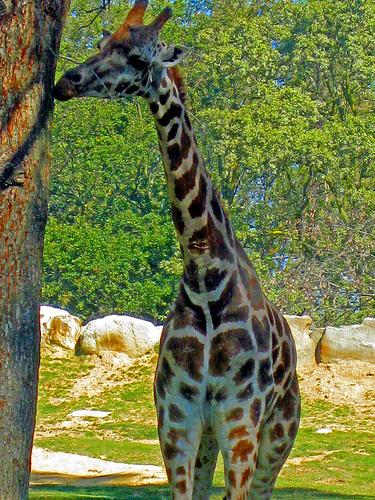Describe the state of the grass where the giraffe is standing. The grass is a mixture of green and exposed dirt, possibly due to the giraffe and other animals' movements in the area. Examine the overall sentiment or mood conveyed by the image. The image conveys a serene and peaceful mood, with a giraffe in its natural habitat surrounded by lush greenery, large rocks, and clear blue skies. Comment on the relationship between the giraffe and its surroundings. The giraffe appears to be comfortable and at ease in its natural environment, interacting with its surroundings by eating leaves from the tree and standing near various elements like rocks and grass. What is the state of the flora surrounding the giraffe? The flora includes bright yellow and greenish-yellow leaves on tall trees, green bushes, and branches with deep green leaves. Identify any anomalies or oddities within the image. A "zebra's mouth" is mentioned on a tree, which is likely an error, as there are no zebras in the image. What kind of tree is the giraffe interacting with in the image? The specific tree type is not identified, but it has a tall and rough trunk with bright yellow and deep green leaves, and branches that extend from the tree. Identify any striking features of the giraffe in the image. The giraffe has long neck, long legs, big and dark eye, ossicones, and a small white spot on its body. Provide a brief description of the most prominent figure in the image. A tall spotted brown and white giraffe is eating from a tree and touching it with its mouth. Explain the environment where the giraffe is standing. The giraffe is standing next to a tall tree, surrounded by green grass and large rocks, with green trees and blue sky peeking through the branches. Analyze the textures and colors of the tree trunk and rocks in the image. The tree trunk has a rough texture with gray and brown colors and black lines, while the large rocks are tan and brown with a big appearance. What type of leaves can be seen on the tall trees in the image? Bright greenish-yellow leaves Can you find a swimming turtle near the tall tree? There is no mention of any turtle or aquatic features in the image. The instruction introduces an object that doesn't exist in the image. Based on the background elements, describe the environment in the image. The environment consists of green grass, large rocks, green bushes, and tall trees with greenish-yellow leaves. Describe the grass area in the picture. The grass is green with patches of exposed dirt. Evaluate the presence of zebras in the image. There are no zebras in the image. Is there a red fruit hanging from the branches with deep green leaves? There is no mention of any fruit or red color in the given information. The instruction introduces an additional attribute and object that doesn't exist in the image. What activity is the giraffe performing in the image? The giraffe is eating leaves from the tree. Are there any flamingos standing on one leg in the background? There is no mention of any flamingos or other animals apart from the giraffe in the given information. The instruction introduces an object that doesn't exist in the image. Describe the nature of the tree trunk in the image. The tree trunk is rough with grey and brown tones. Does the giraffe have bright pink spots all over its body? The given information mentions that the giraffe is brown and has a long spotted neck but doesn't mention any color for the spots. The instruction introduces an attribute (pink spots) that doesn't exist in the image. Can you see the blue sky through the tree branches? Yes, the blue sky is peeking through the branches. Is there a rainbow visible through the greenish yellow leaves on the tall trees? There is no mention of a rainbow in the given information. The instruction introduces an attribute that doesn't exist in the image. What is behind the giraffe in the image? Rocks and green bushes are behind the giraffe. Examine the two lines on the tree trunk and describe them. One line is a long black line and the other is a smaller black fading line. Are the giraffe's ossicones visible in the image? Yes, the giraffe's ossicones are visible. Create a description of the giraffe's body features in the image. The giraffe has a long neck, long legs, a spotted body, big and dark eyes, and ossicones on its head. What is the color of the giraffe in the image? Brown and white Is there an object in the scene that could be referred to as a square white stone? Yes, there is a square white stone on the ground. How many tree branches can you see in the image with deep green leaves? Cannot determine an exact amount. Is the sky behind the giraffe filled with purple clouds? There is no mention of clouds or purple color in the given information, only a mention of the blue sky peeking through branches. The instruction introduces an attribute that doesn't exist in the image. How do you describe the color and size of the rocks in the image? The rocks are big, tan, and brown. Read the text present in the image. There is no text or OCR in the image. Which of the following describes the giraffe's position in relation to the tree: Standing next to the tree, Far from the tree, Sitting under the tree, Behind the tree? Standing next to the tree Is the giraffe standing or sitting? The giraffe is standing. Create a sentence describing where the giraffe is eating from in the image. The giraffe is eating leaves from a tall tree with its long neck. 